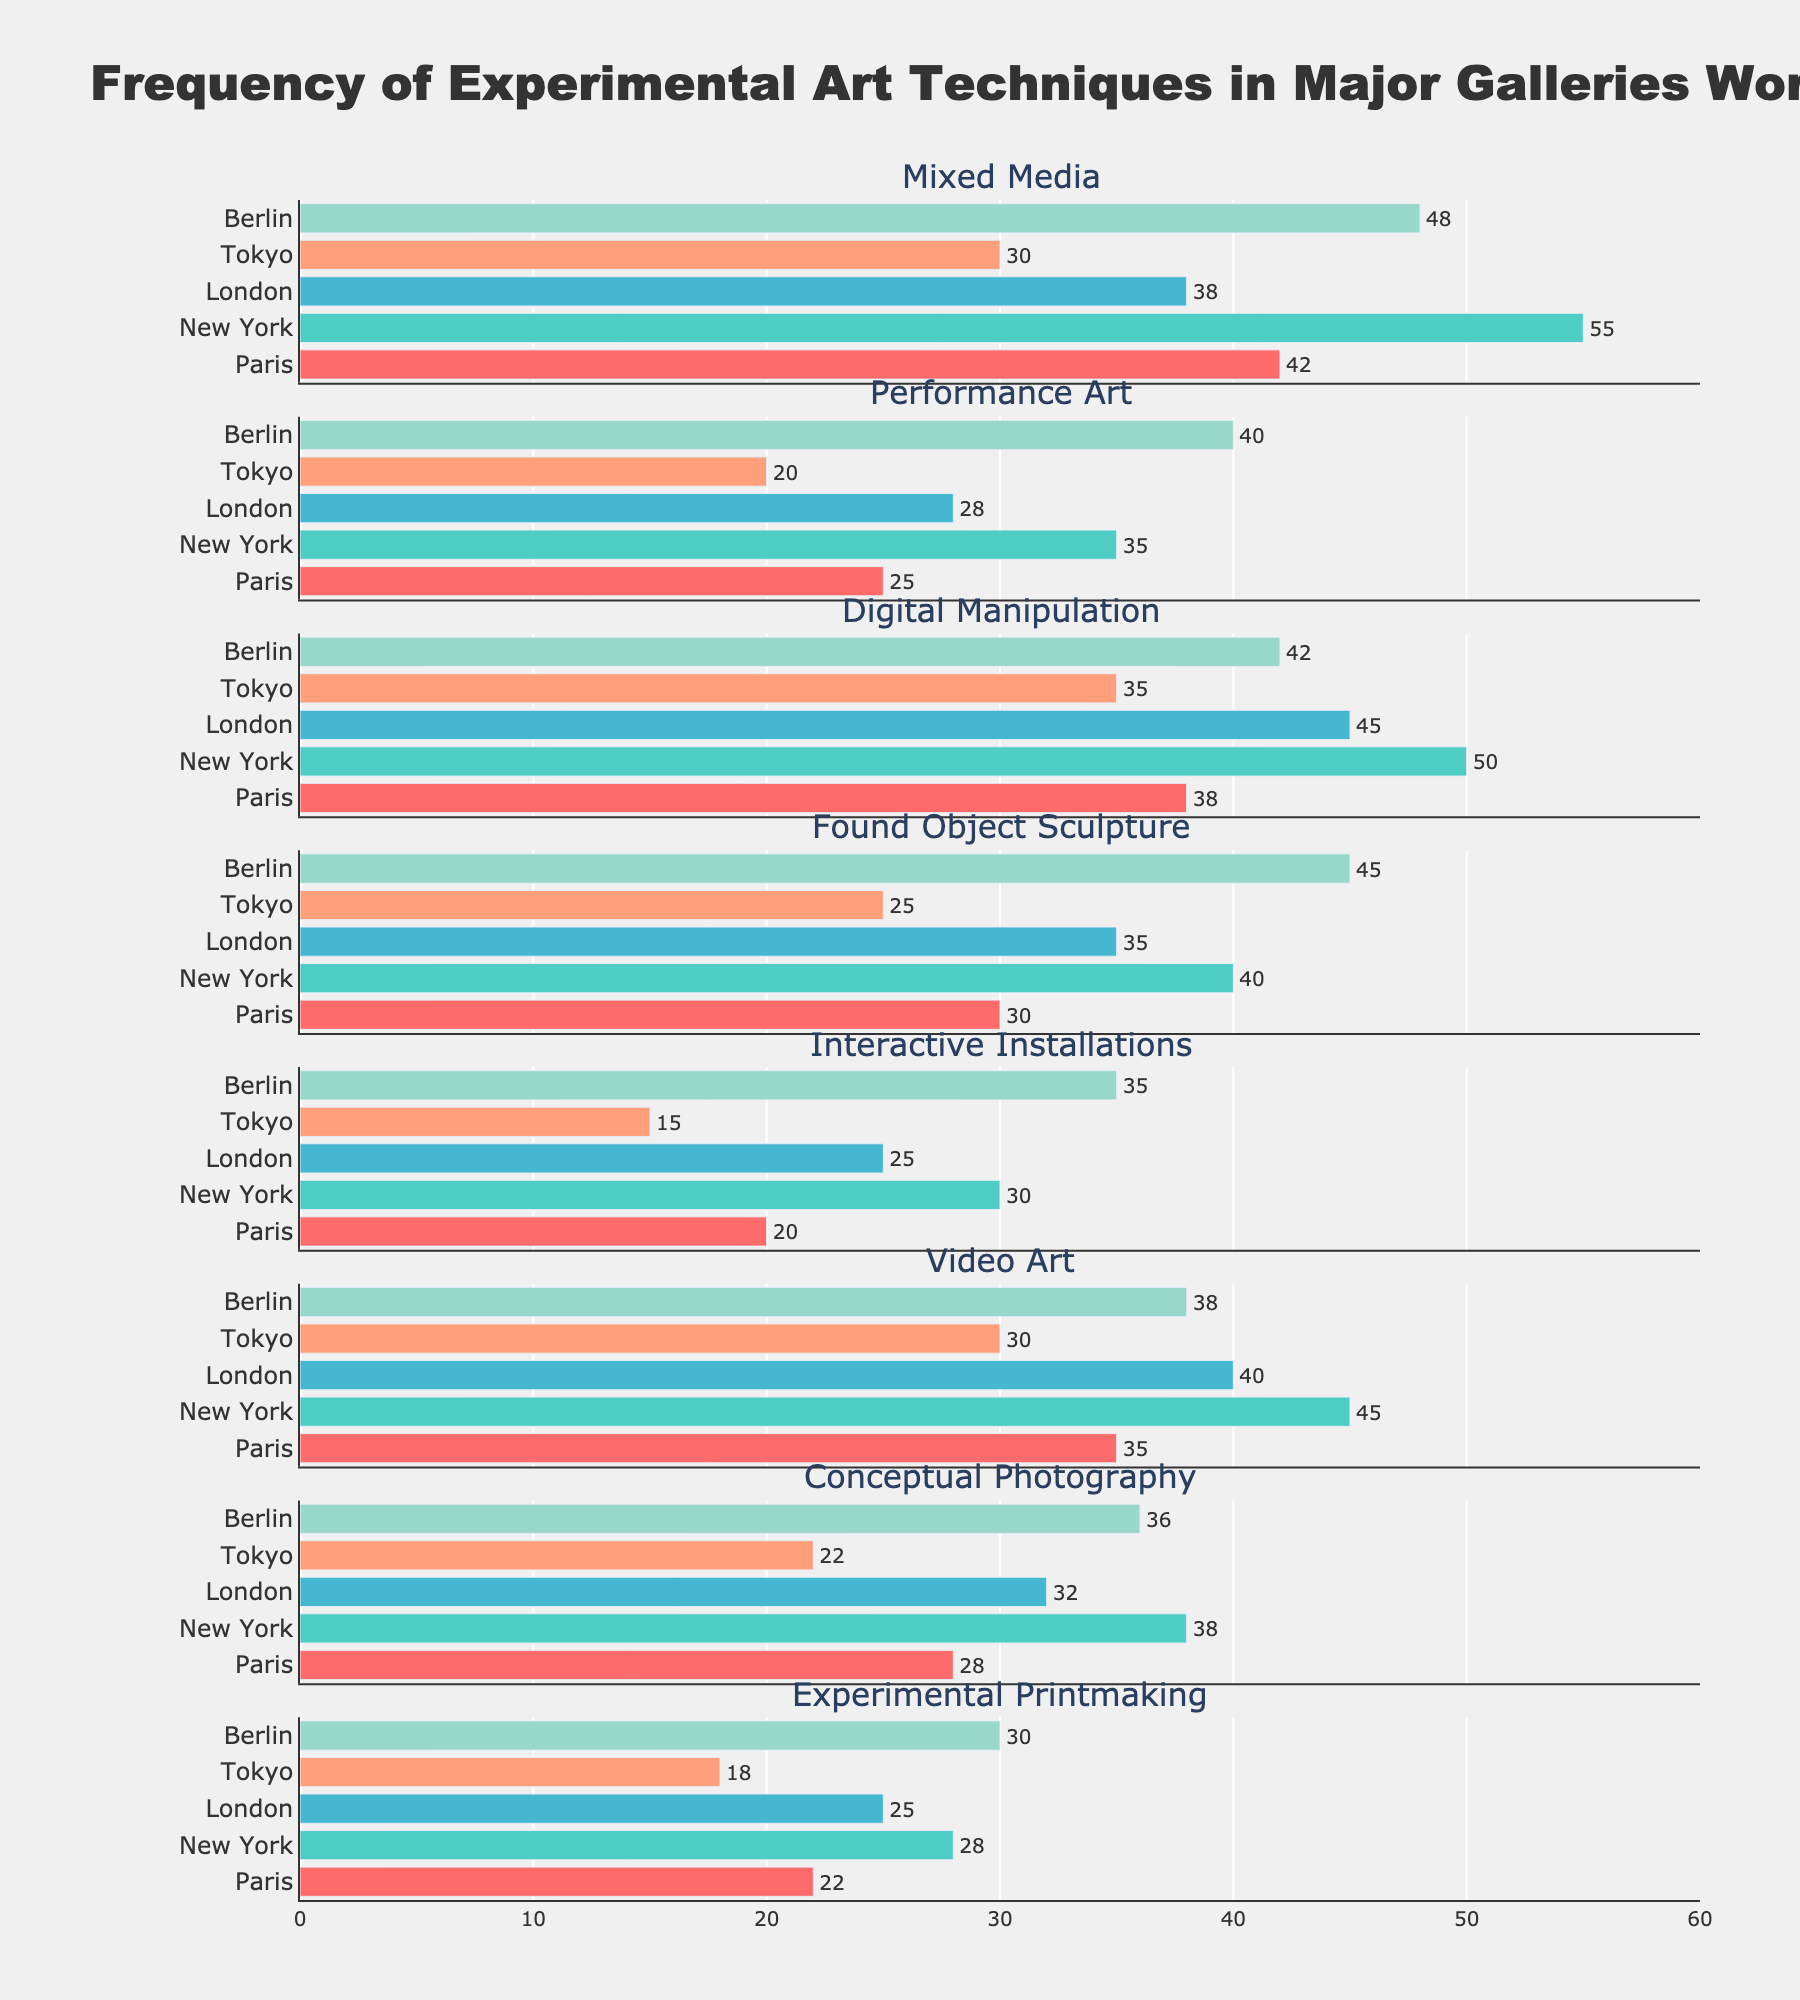Which city has the highest usage of Mixed Media? By examining the subplot for Mixed Media, the bar for New York is the longest, indicating the highest usage.
Answer: New York What is the overall frequency of Performance Art across all cities? Add the frequencies of Performance Art for each city: 25 (Paris) + 35 (New York) + 28 (London) + 20 (Tokyo) + 40 (Berlin) = 148
Answer: 148 Which art technique is least frequently employed in Tokyo? Look at the shortest bars in the Tokyo column across all subplots. The shortest bar corresponds to Interactive Installations with a frequency of 15.
Answer: Interactive Installations How many techniques have a frequency of more than 40 in Berlin? Count the bars higher than 40 in the Berlin column across all subplots: Mixed Media, Performance Art, Digital Manipulation, and Found Object Sculpture. There are 4 techniques.
Answer: 4 What is the range of frequencies for Digital Manipulation across all cities? Identify the maximum and minimum frequency values for Digital Manipulation across the cities: 50 (New York) and 35 (Tokyo). The range is 50 - 35 = 15
Answer: 15 Which city shows the highest variation in frequencies of experimental art techniques? To find the city with the highest variation, calculate the range for each city:
- Paris: max 42, min 20 (range 22)
- New York: max 55, min 28 (range 27)
- London: max 45, min 25 (range 20)
- Tokyo: max 35, min 15 (range 20)
- Berlin: max 48, min 30 (range 18)
New York shows the highest variation of 27.
Answer: New York How does the usage of Video Art in London compare to Paris? Compare the heights of the bars for Video Art in the London and Paris subplots. London has a bar of 40, while Paris has a bar of 35. Therefore, Video Art is slightly more used in London than Paris.
Answer: London What is the average frequency of Conceptual Photography across New York, London, and Berlin? Calculate the average of the frequencies for Conceptual Photography in the specified cities: (38 + 32 + 36) / 3 = 35.33.
Answer: 35.33 